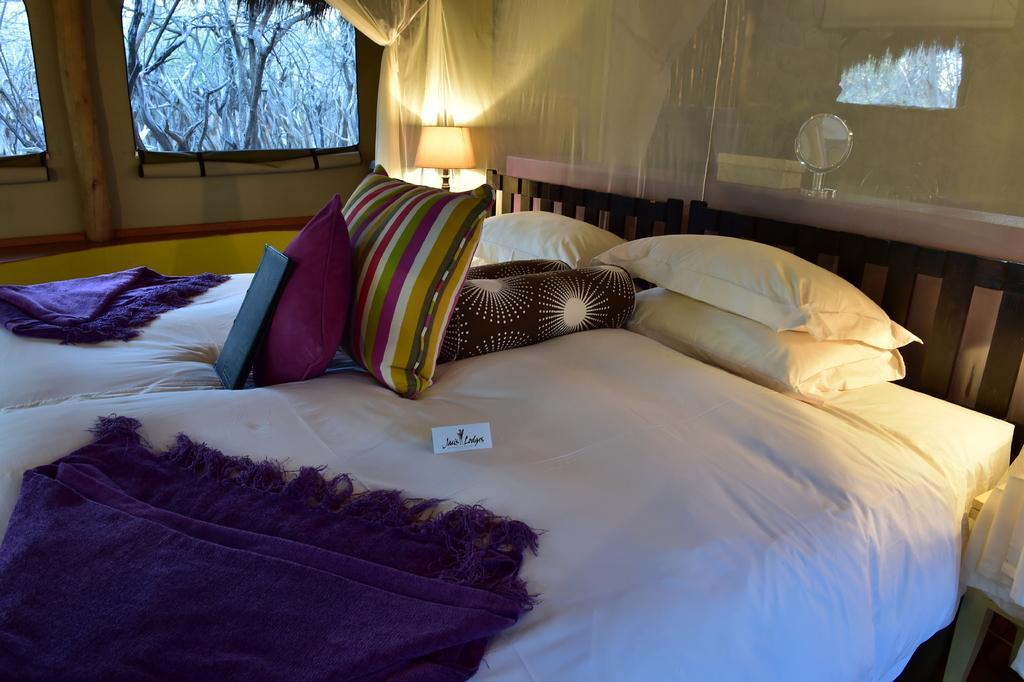How would you summarize this image in a sentence or two? This is a picture taken in a room, this is a bed and the bed is covered with white cloth on the bed there are bed sheets, pillows, file and a paper. Behind the bed there is a lamp, curtain and a glass window. 